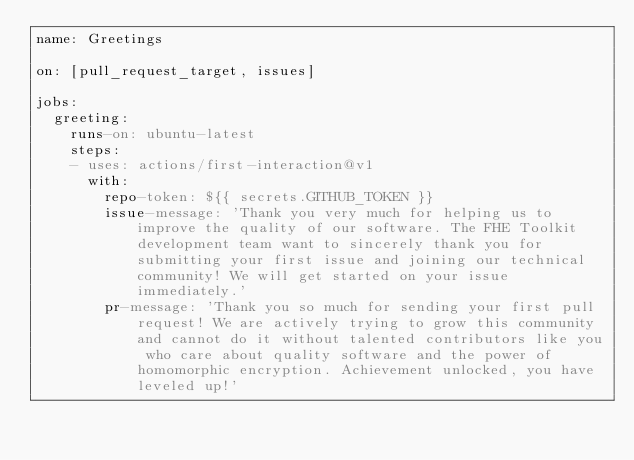<code> <loc_0><loc_0><loc_500><loc_500><_YAML_>name: Greetings

on: [pull_request_target, issues]

jobs:
  greeting:
    runs-on: ubuntu-latest
    steps:
    - uses: actions/first-interaction@v1
      with:
        repo-token: ${{ secrets.GITHUB_TOKEN }}
        issue-message: 'Thank you very much for helping us to improve the quality of our software. The FHE Toolkit development team want to sincerely thank you for submitting your first issue and joining our technical community! We will get started on your issue immediately.'
        pr-message: 'Thank you so much for sending your first pull request! We are actively trying to grow this community and cannot do it without talented contributors like you who care about quality software and the power of homomorphic encryption. Achievement unlocked, you have leveled up!'
</code> 